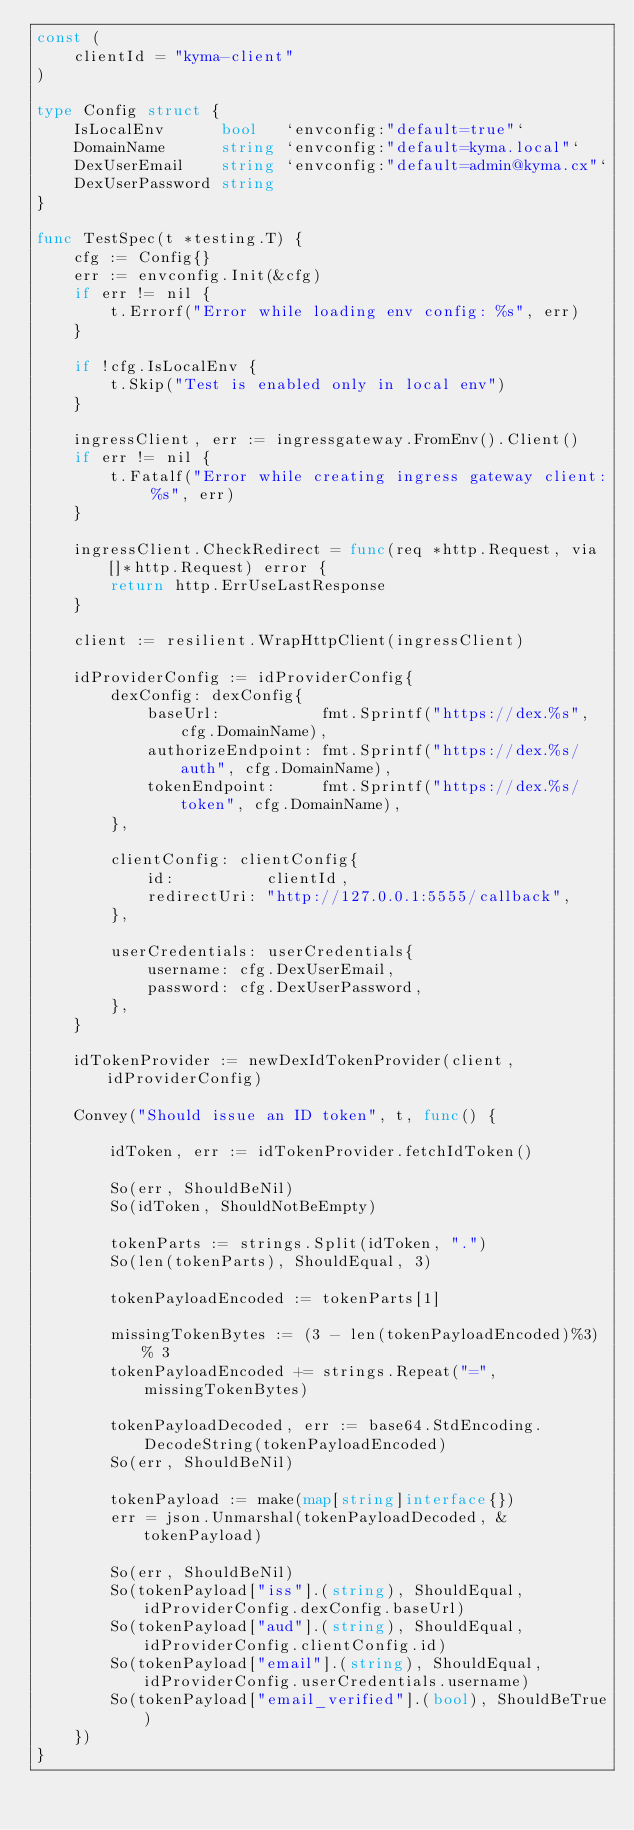Convert code to text. <code><loc_0><loc_0><loc_500><loc_500><_Go_>const (
	clientId = "kyma-client"
)

type Config struct {
	IsLocalEnv      bool   `envconfig:"default=true"`
	DomainName      string `envconfig:"default=kyma.local"`
	DexUserEmail    string `envconfig:"default=admin@kyma.cx"`
	DexUserPassword string
}

func TestSpec(t *testing.T) {
	cfg := Config{}
	err := envconfig.Init(&cfg)
	if err != nil {
		t.Errorf("Error while loading env config: %s", err)
	}

	if !cfg.IsLocalEnv {
		t.Skip("Test is enabled only in local env")
	}

	ingressClient, err := ingressgateway.FromEnv().Client()
	if err != nil {
		t.Fatalf("Error while creating ingress gateway client: %s", err)
	}

	ingressClient.CheckRedirect = func(req *http.Request, via []*http.Request) error {
		return http.ErrUseLastResponse
	}

	client := resilient.WrapHttpClient(ingressClient)

	idProviderConfig := idProviderConfig{
		dexConfig: dexConfig{
			baseUrl:           fmt.Sprintf("https://dex.%s", cfg.DomainName),
			authorizeEndpoint: fmt.Sprintf("https://dex.%s/auth", cfg.DomainName),
			tokenEndpoint:     fmt.Sprintf("https://dex.%s/token", cfg.DomainName),
		},

		clientConfig: clientConfig{
			id:          clientId,
			redirectUri: "http://127.0.0.1:5555/callback",
		},

		userCredentials: userCredentials{
			username: cfg.DexUserEmail,
			password: cfg.DexUserPassword,
		},
	}

	idTokenProvider := newDexIdTokenProvider(client, idProviderConfig)

	Convey("Should issue an ID token", t, func() {

		idToken, err := idTokenProvider.fetchIdToken()

		So(err, ShouldBeNil)
		So(idToken, ShouldNotBeEmpty)

		tokenParts := strings.Split(idToken, ".")
		So(len(tokenParts), ShouldEqual, 3)

		tokenPayloadEncoded := tokenParts[1]

		missingTokenBytes := (3 - len(tokenPayloadEncoded)%3) % 3
		tokenPayloadEncoded += strings.Repeat("=", missingTokenBytes)

		tokenPayloadDecoded, err := base64.StdEncoding.DecodeString(tokenPayloadEncoded)
		So(err, ShouldBeNil)

		tokenPayload := make(map[string]interface{})
		err = json.Unmarshal(tokenPayloadDecoded, &tokenPayload)

		So(err, ShouldBeNil)
		So(tokenPayload["iss"].(string), ShouldEqual, idProviderConfig.dexConfig.baseUrl)
		So(tokenPayload["aud"].(string), ShouldEqual, idProviderConfig.clientConfig.id)
		So(tokenPayload["email"].(string), ShouldEqual, idProviderConfig.userCredentials.username)
		So(tokenPayload["email_verified"].(bool), ShouldBeTrue)
	})
}
</code> 